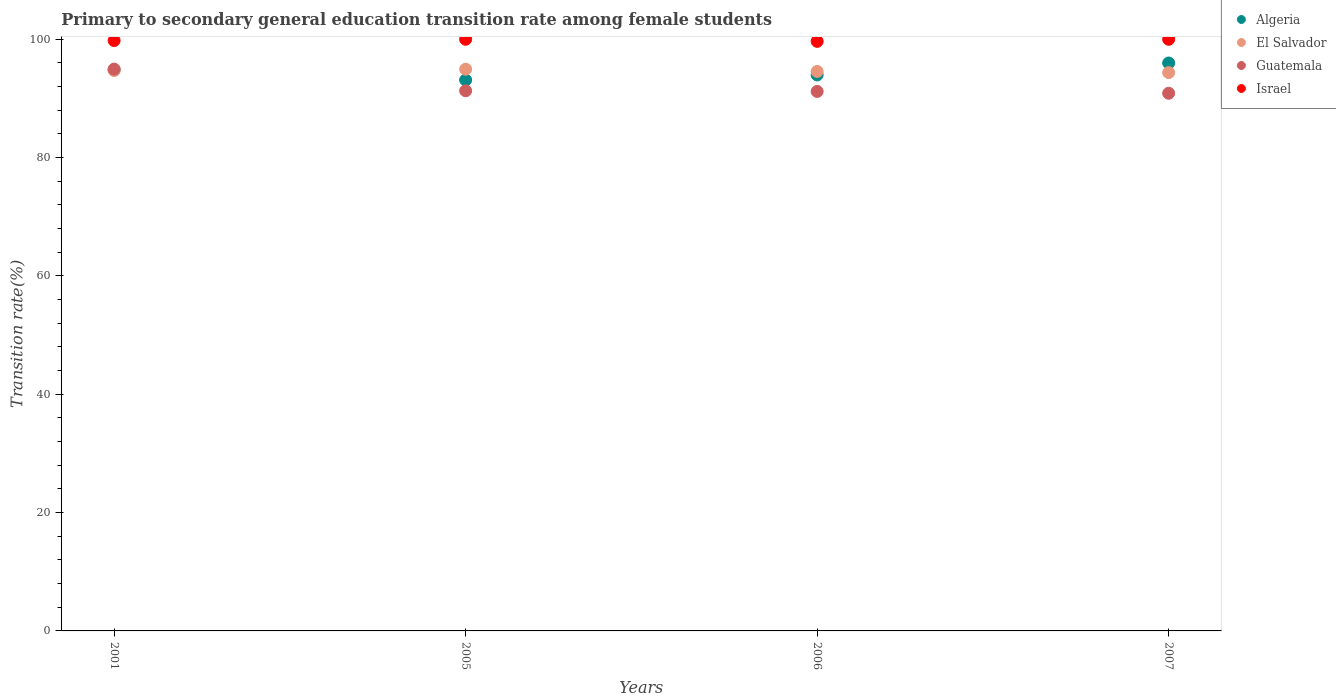How many different coloured dotlines are there?
Provide a succinct answer. 4. Is the number of dotlines equal to the number of legend labels?
Your answer should be very brief. Yes. What is the transition rate in Algeria in 2007?
Make the answer very short. 95.99. Across all years, what is the maximum transition rate in Algeria?
Your response must be concise. 95.99. Across all years, what is the minimum transition rate in Israel?
Your response must be concise. 99.65. In which year was the transition rate in Israel minimum?
Offer a very short reply. 2006. What is the total transition rate in Algeria in the graph?
Provide a succinct answer. 377.91. What is the difference between the transition rate in Guatemala in 2006 and that in 2007?
Your answer should be compact. 0.31. What is the difference between the transition rate in Algeria in 2005 and the transition rate in Israel in 2007?
Provide a short and direct response. -6.88. What is the average transition rate in El Salvador per year?
Give a very brief answer. 94.65. In the year 2005, what is the difference between the transition rate in Israel and transition rate in Guatemala?
Keep it short and to the point. 8.7. What is the ratio of the transition rate in Guatemala in 2005 to that in 2006?
Offer a very short reply. 1. Is the transition rate in Israel in 2001 less than that in 2007?
Make the answer very short. Yes. Is the difference between the transition rate in Israel in 2005 and 2007 greater than the difference between the transition rate in Guatemala in 2005 and 2007?
Your response must be concise. No. What is the difference between the highest and the second highest transition rate in Israel?
Offer a very short reply. 0. What is the difference between the highest and the lowest transition rate in Guatemala?
Give a very brief answer. 4.08. In how many years, is the transition rate in Algeria greater than the average transition rate in Algeria taken over all years?
Give a very brief answer. 2. Is the sum of the transition rate in Guatemala in 2001 and 2005 greater than the maximum transition rate in El Salvador across all years?
Offer a very short reply. Yes. Is the transition rate in El Salvador strictly greater than the transition rate in Guatemala over the years?
Make the answer very short. No. How many dotlines are there?
Provide a succinct answer. 4. How many years are there in the graph?
Offer a terse response. 4. Are the values on the major ticks of Y-axis written in scientific E-notation?
Make the answer very short. No. Where does the legend appear in the graph?
Your answer should be compact. Top right. How are the legend labels stacked?
Your answer should be very brief. Vertical. What is the title of the graph?
Offer a terse response. Primary to secondary general education transition rate among female students. Does "High income" appear as one of the legend labels in the graph?
Make the answer very short. No. What is the label or title of the X-axis?
Your response must be concise. Years. What is the label or title of the Y-axis?
Provide a short and direct response. Transition rate(%). What is the Transition rate(%) of Algeria in 2001?
Your response must be concise. 94.82. What is the Transition rate(%) in El Salvador in 2001?
Your answer should be very brief. 94.73. What is the Transition rate(%) in Guatemala in 2001?
Make the answer very short. 94.96. What is the Transition rate(%) in Israel in 2001?
Your answer should be compact. 99.79. What is the Transition rate(%) in Algeria in 2005?
Ensure brevity in your answer.  93.12. What is the Transition rate(%) of El Salvador in 2005?
Provide a short and direct response. 94.94. What is the Transition rate(%) of Guatemala in 2005?
Offer a very short reply. 91.3. What is the Transition rate(%) in Israel in 2005?
Ensure brevity in your answer.  100. What is the Transition rate(%) of Algeria in 2006?
Make the answer very short. 93.97. What is the Transition rate(%) of El Salvador in 2006?
Your response must be concise. 94.56. What is the Transition rate(%) in Guatemala in 2006?
Ensure brevity in your answer.  91.18. What is the Transition rate(%) in Israel in 2006?
Offer a terse response. 99.65. What is the Transition rate(%) in Algeria in 2007?
Ensure brevity in your answer.  95.99. What is the Transition rate(%) of El Salvador in 2007?
Provide a succinct answer. 94.37. What is the Transition rate(%) in Guatemala in 2007?
Provide a succinct answer. 90.88. Across all years, what is the maximum Transition rate(%) in Algeria?
Make the answer very short. 95.99. Across all years, what is the maximum Transition rate(%) in El Salvador?
Offer a very short reply. 94.94. Across all years, what is the maximum Transition rate(%) in Guatemala?
Make the answer very short. 94.96. Across all years, what is the maximum Transition rate(%) in Israel?
Ensure brevity in your answer.  100. Across all years, what is the minimum Transition rate(%) in Algeria?
Ensure brevity in your answer.  93.12. Across all years, what is the minimum Transition rate(%) of El Salvador?
Give a very brief answer. 94.37. Across all years, what is the minimum Transition rate(%) in Guatemala?
Your answer should be compact. 90.88. Across all years, what is the minimum Transition rate(%) in Israel?
Your answer should be compact. 99.65. What is the total Transition rate(%) in Algeria in the graph?
Make the answer very short. 377.91. What is the total Transition rate(%) of El Salvador in the graph?
Keep it short and to the point. 378.6. What is the total Transition rate(%) in Guatemala in the graph?
Make the answer very short. 368.31. What is the total Transition rate(%) of Israel in the graph?
Keep it short and to the point. 399.44. What is the difference between the Transition rate(%) of Algeria in 2001 and that in 2005?
Offer a terse response. 1.7. What is the difference between the Transition rate(%) of El Salvador in 2001 and that in 2005?
Provide a succinct answer. -0.21. What is the difference between the Transition rate(%) in Guatemala in 2001 and that in 2005?
Your response must be concise. 3.66. What is the difference between the Transition rate(%) in Israel in 2001 and that in 2005?
Make the answer very short. -0.21. What is the difference between the Transition rate(%) of Algeria in 2001 and that in 2006?
Offer a terse response. 0.85. What is the difference between the Transition rate(%) in El Salvador in 2001 and that in 2006?
Provide a succinct answer. 0.17. What is the difference between the Transition rate(%) of Guatemala in 2001 and that in 2006?
Your response must be concise. 3.78. What is the difference between the Transition rate(%) of Israel in 2001 and that in 2006?
Offer a very short reply. 0.14. What is the difference between the Transition rate(%) in Algeria in 2001 and that in 2007?
Your answer should be compact. -1.17. What is the difference between the Transition rate(%) in El Salvador in 2001 and that in 2007?
Ensure brevity in your answer.  0.36. What is the difference between the Transition rate(%) in Guatemala in 2001 and that in 2007?
Your response must be concise. 4.08. What is the difference between the Transition rate(%) in Israel in 2001 and that in 2007?
Keep it short and to the point. -0.21. What is the difference between the Transition rate(%) of Algeria in 2005 and that in 2006?
Offer a very short reply. -0.85. What is the difference between the Transition rate(%) of El Salvador in 2005 and that in 2006?
Provide a short and direct response. 0.37. What is the difference between the Transition rate(%) of Guatemala in 2005 and that in 2006?
Make the answer very short. 0.11. What is the difference between the Transition rate(%) in Israel in 2005 and that in 2006?
Your response must be concise. 0.35. What is the difference between the Transition rate(%) of Algeria in 2005 and that in 2007?
Your answer should be compact. -2.87. What is the difference between the Transition rate(%) in El Salvador in 2005 and that in 2007?
Ensure brevity in your answer.  0.56. What is the difference between the Transition rate(%) of Guatemala in 2005 and that in 2007?
Provide a short and direct response. 0.42. What is the difference between the Transition rate(%) in Israel in 2005 and that in 2007?
Your answer should be very brief. 0. What is the difference between the Transition rate(%) in Algeria in 2006 and that in 2007?
Offer a very short reply. -2.02. What is the difference between the Transition rate(%) of El Salvador in 2006 and that in 2007?
Keep it short and to the point. 0.19. What is the difference between the Transition rate(%) in Guatemala in 2006 and that in 2007?
Provide a short and direct response. 0.31. What is the difference between the Transition rate(%) in Israel in 2006 and that in 2007?
Provide a short and direct response. -0.35. What is the difference between the Transition rate(%) in Algeria in 2001 and the Transition rate(%) in El Salvador in 2005?
Keep it short and to the point. -0.11. What is the difference between the Transition rate(%) in Algeria in 2001 and the Transition rate(%) in Guatemala in 2005?
Provide a short and direct response. 3.53. What is the difference between the Transition rate(%) in Algeria in 2001 and the Transition rate(%) in Israel in 2005?
Keep it short and to the point. -5.18. What is the difference between the Transition rate(%) in El Salvador in 2001 and the Transition rate(%) in Guatemala in 2005?
Give a very brief answer. 3.43. What is the difference between the Transition rate(%) of El Salvador in 2001 and the Transition rate(%) of Israel in 2005?
Provide a succinct answer. -5.27. What is the difference between the Transition rate(%) of Guatemala in 2001 and the Transition rate(%) of Israel in 2005?
Your answer should be very brief. -5.04. What is the difference between the Transition rate(%) of Algeria in 2001 and the Transition rate(%) of El Salvador in 2006?
Provide a short and direct response. 0.26. What is the difference between the Transition rate(%) in Algeria in 2001 and the Transition rate(%) in Guatemala in 2006?
Ensure brevity in your answer.  3.64. What is the difference between the Transition rate(%) of Algeria in 2001 and the Transition rate(%) of Israel in 2006?
Offer a very short reply. -4.83. What is the difference between the Transition rate(%) in El Salvador in 2001 and the Transition rate(%) in Guatemala in 2006?
Make the answer very short. 3.55. What is the difference between the Transition rate(%) of El Salvador in 2001 and the Transition rate(%) of Israel in 2006?
Your answer should be compact. -4.92. What is the difference between the Transition rate(%) in Guatemala in 2001 and the Transition rate(%) in Israel in 2006?
Your answer should be compact. -4.69. What is the difference between the Transition rate(%) in Algeria in 2001 and the Transition rate(%) in El Salvador in 2007?
Offer a terse response. 0.45. What is the difference between the Transition rate(%) in Algeria in 2001 and the Transition rate(%) in Guatemala in 2007?
Your answer should be very brief. 3.95. What is the difference between the Transition rate(%) in Algeria in 2001 and the Transition rate(%) in Israel in 2007?
Your response must be concise. -5.18. What is the difference between the Transition rate(%) in El Salvador in 2001 and the Transition rate(%) in Guatemala in 2007?
Your answer should be compact. 3.85. What is the difference between the Transition rate(%) in El Salvador in 2001 and the Transition rate(%) in Israel in 2007?
Ensure brevity in your answer.  -5.27. What is the difference between the Transition rate(%) of Guatemala in 2001 and the Transition rate(%) of Israel in 2007?
Provide a succinct answer. -5.04. What is the difference between the Transition rate(%) of Algeria in 2005 and the Transition rate(%) of El Salvador in 2006?
Keep it short and to the point. -1.44. What is the difference between the Transition rate(%) in Algeria in 2005 and the Transition rate(%) in Guatemala in 2006?
Keep it short and to the point. 1.94. What is the difference between the Transition rate(%) of Algeria in 2005 and the Transition rate(%) of Israel in 2006?
Offer a terse response. -6.53. What is the difference between the Transition rate(%) of El Salvador in 2005 and the Transition rate(%) of Guatemala in 2006?
Your answer should be compact. 3.75. What is the difference between the Transition rate(%) in El Salvador in 2005 and the Transition rate(%) in Israel in 2006?
Offer a terse response. -4.71. What is the difference between the Transition rate(%) in Guatemala in 2005 and the Transition rate(%) in Israel in 2006?
Your answer should be very brief. -8.35. What is the difference between the Transition rate(%) of Algeria in 2005 and the Transition rate(%) of El Salvador in 2007?
Make the answer very short. -1.25. What is the difference between the Transition rate(%) in Algeria in 2005 and the Transition rate(%) in Guatemala in 2007?
Your response must be concise. 2.25. What is the difference between the Transition rate(%) of Algeria in 2005 and the Transition rate(%) of Israel in 2007?
Provide a succinct answer. -6.88. What is the difference between the Transition rate(%) in El Salvador in 2005 and the Transition rate(%) in Guatemala in 2007?
Make the answer very short. 4.06. What is the difference between the Transition rate(%) of El Salvador in 2005 and the Transition rate(%) of Israel in 2007?
Offer a very short reply. -5.06. What is the difference between the Transition rate(%) of Guatemala in 2005 and the Transition rate(%) of Israel in 2007?
Offer a terse response. -8.7. What is the difference between the Transition rate(%) of Algeria in 2006 and the Transition rate(%) of El Salvador in 2007?
Provide a short and direct response. -0.4. What is the difference between the Transition rate(%) of Algeria in 2006 and the Transition rate(%) of Guatemala in 2007?
Make the answer very short. 3.1. What is the difference between the Transition rate(%) in Algeria in 2006 and the Transition rate(%) in Israel in 2007?
Offer a very short reply. -6.03. What is the difference between the Transition rate(%) of El Salvador in 2006 and the Transition rate(%) of Guatemala in 2007?
Provide a short and direct response. 3.69. What is the difference between the Transition rate(%) of El Salvador in 2006 and the Transition rate(%) of Israel in 2007?
Your answer should be compact. -5.44. What is the difference between the Transition rate(%) of Guatemala in 2006 and the Transition rate(%) of Israel in 2007?
Provide a succinct answer. -8.82. What is the average Transition rate(%) in Algeria per year?
Offer a terse response. 94.48. What is the average Transition rate(%) in El Salvador per year?
Give a very brief answer. 94.65. What is the average Transition rate(%) in Guatemala per year?
Offer a very short reply. 92.08. What is the average Transition rate(%) in Israel per year?
Your answer should be compact. 99.86. In the year 2001, what is the difference between the Transition rate(%) of Algeria and Transition rate(%) of El Salvador?
Offer a very short reply. 0.09. In the year 2001, what is the difference between the Transition rate(%) of Algeria and Transition rate(%) of Guatemala?
Provide a short and direct response. -0.13. In the year 2001, what is the difference between the Transition rate(%) of Algeria and Transition rate(%) of Israel?
Keep it short and to the point. -4.96. In the year 2001, what is the difference between the Transition rate(%) in El Salvador and Transition rate(%) in Guatemala?
Ensure brevity in your answer.  -0.23. In the year 2001, what is the difference between the Transition rate(%) in El Salvador and Transition rate(%) in Israel?
Your answer should be very brief. -5.06. In the year 2001, what is the difference between the Transition rate(%) in Guatemala and Transition rate(%) in Israel?
Your answer should be compact. -4.83. In the year 2005, what is the difference between the Transition rate(%) in Algeria and Transition rate(%) in El Salvador?
Your response must be concise. -1.81. In the year 2005, what is the difference between the Transition rate(%) of Algeria and Transition rate(%) of Guatemala?
Give a very brief answer. 1.83. In the year 2005, what is the difference between the Transition rate(%) of Algeria and Transition rate(%) of Israel?
Provide a short and direct response. -6.88. In the year 2005, what is the difference between the Transition rate(%) of El Salvador and Transition rate(%) of Guatemala?
Ensure brevity in your answer.  3.64. In the year 2005, what is the difference between the Transition rate(%) in El Salvador and Transition rate(%) in Israel?
Keep it short and to the point. -5.06. In the year 2005, what is the difference between the Transition rate(%) of Guatemala and Transition rate(%) of Israel?
Give a very brief answer. -8.7. In the year 2006, what is the difference between the Transition rate(%) in Algeria and Transition rate(%) in El Salvador?
Offer a very short reply. -0.59. In the year 2006, what is the difference between the Transition rate(%) of Algeria and Transition rate(%) of Guatemala?
Offer a terse response. 2.79. In the year 2006, what is the difference between the Transition rate(%) of Algeria and Transition rate(%) of Israel?
Offer a very short reply. -5.68. In the year 2006, what is the difference between the Transition rate(%) of El Salvador and Transition rate(%) of Guatemala?
Your response must be concise. 3.38. In the year 2006, what is the difference between the Transition rate(%) in El Salvador and Transition rate(%) in Israel?
Make the answer very short. -5.09. In the year 2006, what is the difference between the Transition rate(%) of Guatemala and Transition rate(%) of Israel?
Offer a terse response. -8.47. In the year 2007, what is the difference between the Transition rate(%) in Algeria and Transition rate(%) in El Salvador?
Your answer should be compact. 1.62. In the year 2007, what is the difference between the Transition rate(%) in Algeria and Transition rate(%) in Guatemala?
Give a very brief answer. 5.11. In the year 2007, what is the difference between the Transition rate(%) in Algeria and Transition rate(%) in Israel?
Give a very brief answer. -4.01. In the year 2007, what is the difference between the Transition rate(%) in El Salvador and Transition rate(%) in Guatemala?
Offer a very short reply. 3.5. In the year 2007, what is the difference between the Transition rate(%) of El Salvador and Transition rate(%) of Israel?
Your answer should be compact. -5.63. In the year 2007, what is the difference between the Transition rate(%) in Guatemala and Transition rate(%) in Israel?
Your answer should be very brief. -9.12. What is the ratio of the Transition rate(%) of Algeria in 2001 to that in 2005?
Ensure brevity in your answer.  1.02. What is the ratio of the Transition rate(%) in El Salvador in 2001 to that in 2005?
Offer a terse response. 1. What is the ratio of the Transition rate(%) in Guatemala in 2001 to that in 2005?
Provide a succinct answer. 1.04. What is the ratio of the Transition rate(%) of Algeria in 2001 to that in 2006?
Offer a very short reply. 1.01. What is the ratio of the Transition rate(%) of Guatemala in 2001 to that in 2006?
Offer a very short reply. 1.04. What is the ratio of the Transition rate(%) of Israel in 2001 to that in 2006?
Your response must be concise. 1. What is the ratio of the Transition rate(%) of Algeria in 2001 to that in 2007?
Your answer should be very brief. 0.99. What is the ratio of the Transition rate(%) of Guatemala in 2001 to that in 2007?
Your answer should be very brief. 1.04. What is the ratio of the Transition rate(%) of Israel in 2001 to that in 2007?
Your response must be concise. 1. What is the ratio of the Transition rate(%) in El Salvador in 2005 to that in 2006?
Provide a short and direct response. 1. What is the ratio of the Transition rate(%) of Guatemala in 2005 to that in 2006?
Your answer should be compact. 1. What is the ratio of the Transition rate(%) in Israel in 2005 to that in 2006?
Provide a short and direct response. 1. What is the ratio of the Transition rate(%) of Algeria in 2005 to that in 2007?
Make the answer very short. 0.97. What is the ratio of the Transition rate(%) in Israel in 2005 to that in 2007?
Offer a terse response. 1. What is the ratio of the Transition rate(%) of Algeria in 2006 to that in 2007?
Your response must be concise. 0.98. What is the difference between the highest and the second highest Transition rate(%) in Algeria?
Provide a succinct answer. 1.17. What is the difference between the highest and the second highest Transition rate(%) in El Salvador?
Ensure brevity in your answer.  0.21. What is the difference between the highest and the second highest Transition rate(%) in Guatemala?
Your response must be concise. 3.66. What is the difference between the highest and the lowest Transition rate(%) in Algeria?
Your response must be concise. 2.87. What is the difference between the highest and the lowest Transition rate(%) of El Salvador?
Offer a terse response. 0.56. What is the difference between the highest and the lowest Transition rate(%) of Guatemala?
Your response must be concise. 4.08. What is the difference between the highest and the lowest Transition rate(%) in Israel?
Keep it short and to the point. 0.35. 